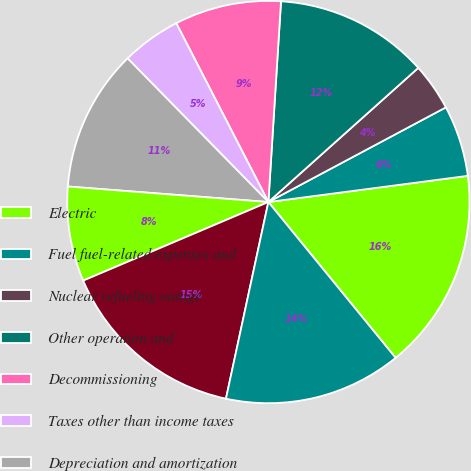Convert chart. <chart><loc_0><loc_0><loc_500><loc_500><pie_chart><fcel>Electric<fcel>Fuel fuel-related expenses and<fcel>Nuclear refueling outage<fcel>Other operation and<fcel>Decommissioning<fcel>Taxes other than income taxes<fcel>Depreciation and amortization<fcel>Other regulatory credits - net<fcel>TOTAL<fcel>OPERATING INCOME<nl><fcel>16.18%<fcel>5.72%<fcel>3.82%<fcel>12.38%<fcel>8.57%<fcel>4.77%<fcel>11.43%<fcel>7.62%<fcel>15.23%<fcel>14.28%<nl></chart> 